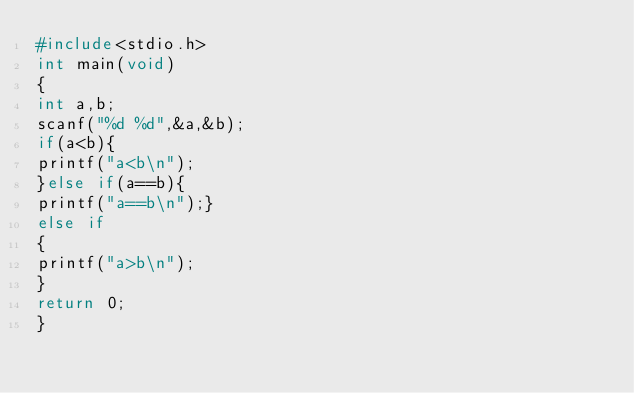<code> <loc_0><loc_0><loc_500><loc_500><_C_>#include<stdio.h>
int main(void)
{
int a,b;
scanf("%d %d",&a,&b);
if(a<b){
printf("a<b\n");
}else if(a==b){
printf("a==b\n");}
else if
{
printf("a>b\n");
}
return 0;
}</code> 